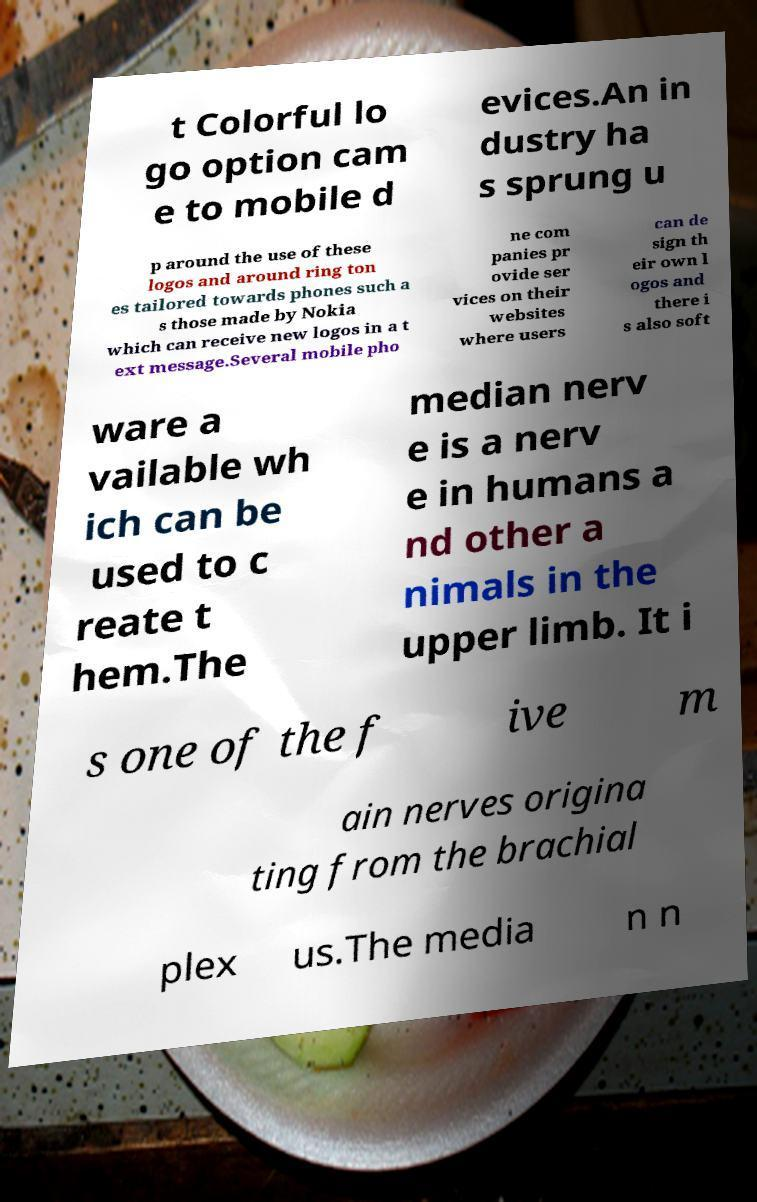Can you read and provide the text displayed in the image?This photo seems to have some interesting text. Can you extract and type it out for me? t Colorful lo go option cam e to mobile d evices.An in dustry ha s sprung u p around the use of these logos and around ring ton es tailored towards phones such a s those made by Nokia which can receive new logos in a t ext message.Several mobile pho ne com panies pr ovide ser vices on their websites where users can de sign th eir own l ogos and there i s also soft ware a vailable wh ich can be used to c reate t hem.The median nerv e is a nerv e in humans a nd other a nimals in the upper limb. It i s one of the f ive m ain nerves origina ting from the brachial plex us.The media n n 